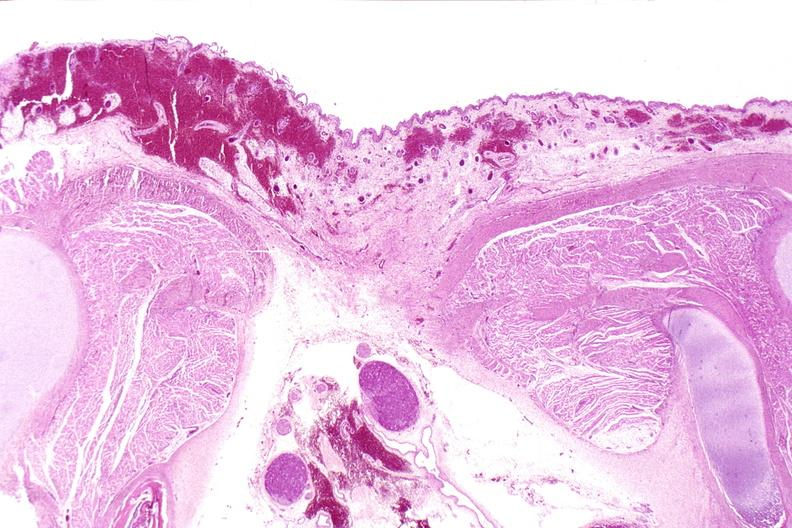what does this image show?
Answer the question using a single word or phrase. Neural tube defect 